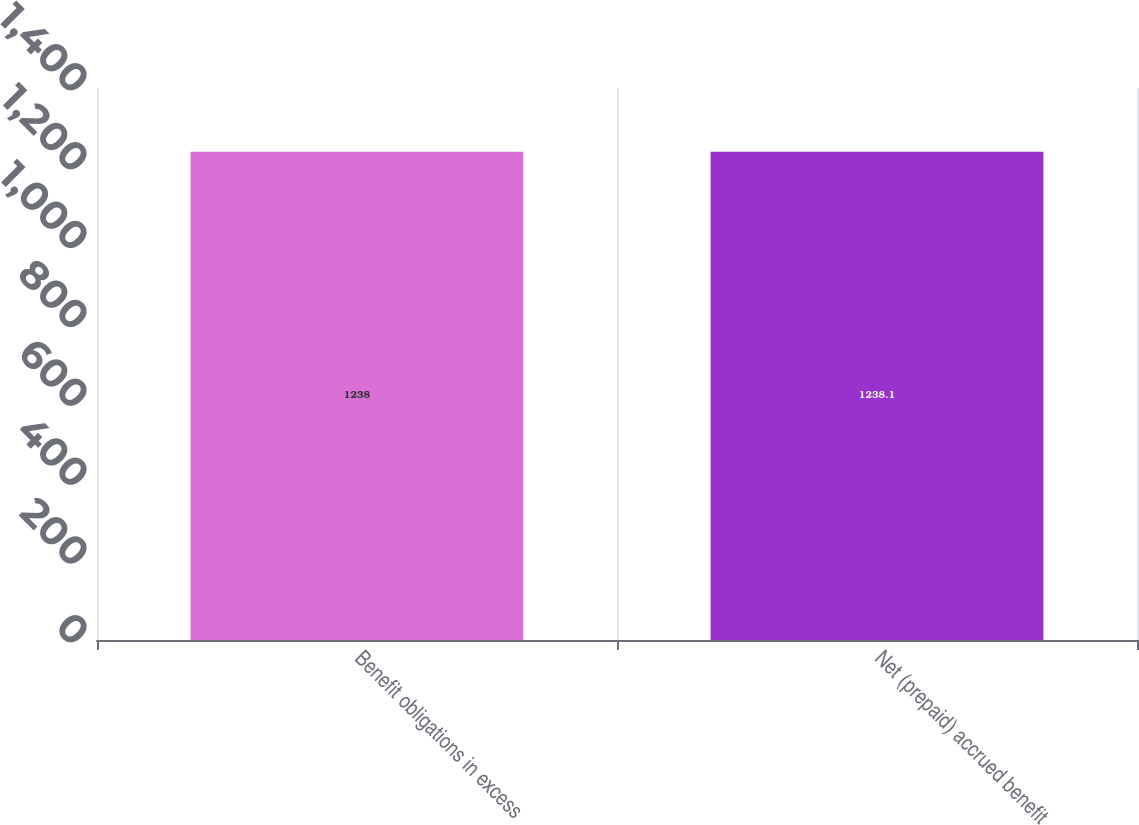Convert chart. <chart><loc_0><loc_0><loc_500><loc_500><bar_chart><fcel>Benefit obligations in excess<fcel>Net (prepaid) accrued benefit<nl><fcel>1238<fcel>1238.1<nl></chart> 